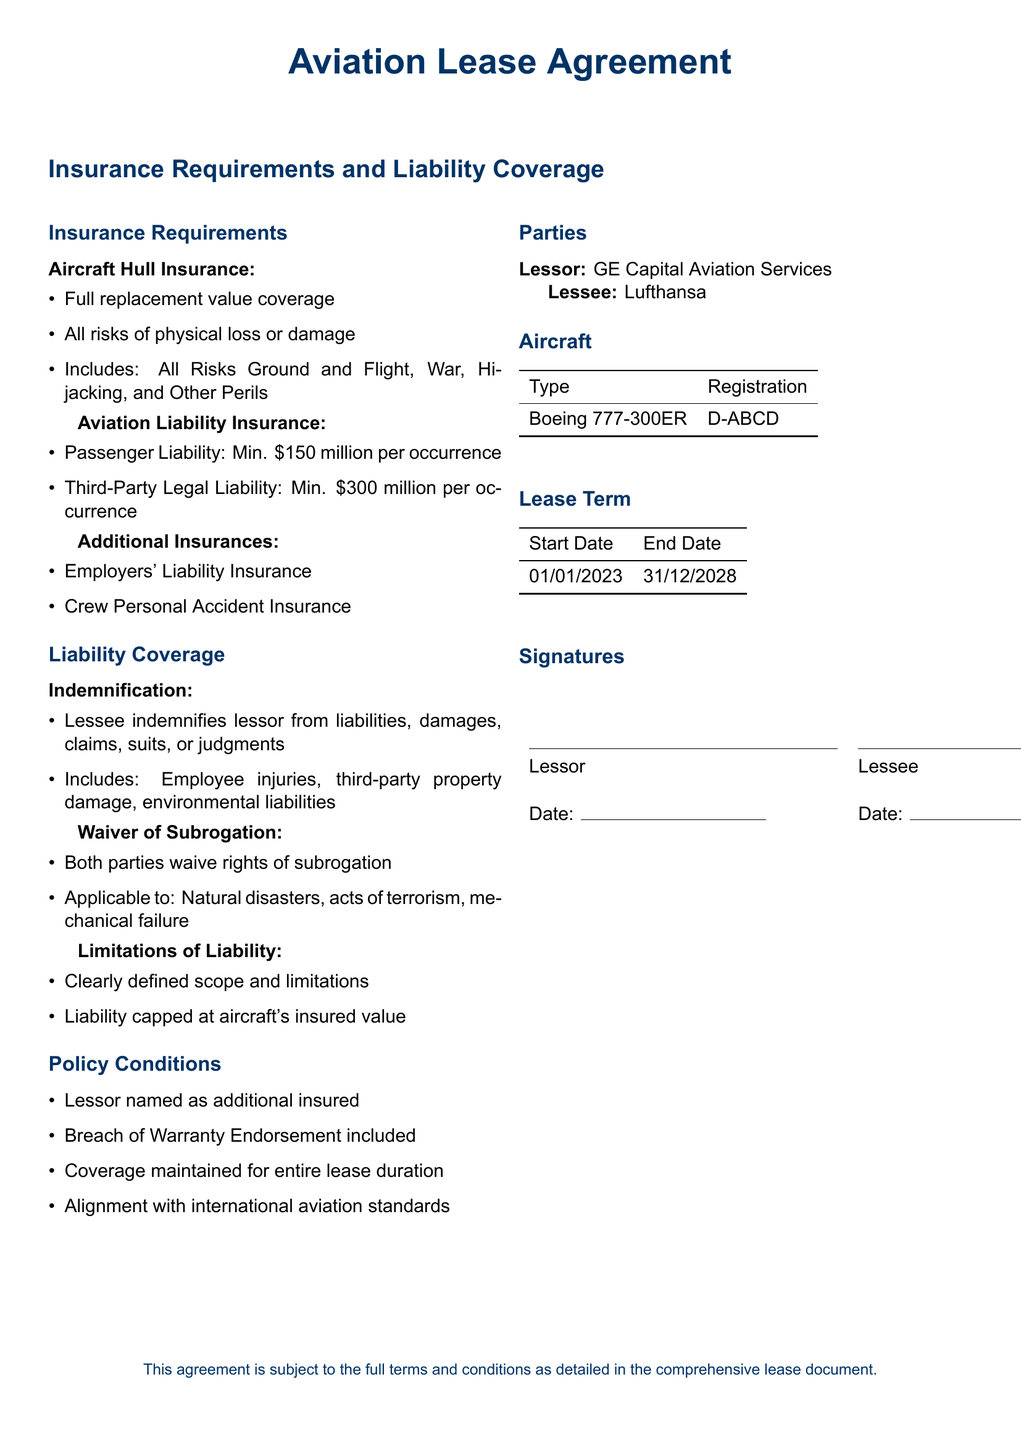What type of insurance is required for the aircraft? The document specifies that Aircraft Hull Insurance is required, covering full replacement value and all risks of physical loss or damage.
Answer: Aircraft Hull Insurance What is the minimum passenger liability coverage per occurrence? The document states that the minimum passenger liability coverage is set at 150 million.
Answer: 150 million Who is the lessor in this agreement? The lessor, as mentioned in the document, is GE Capital Aviation Services.
Answer: GE Capital Aviation Services What is the limit of liability according to the document? The document indicates that liability is capped at the aircraft's insured value.
Answer: Aircraft's insured value What type of aircraft is mentioned in the lease agreement? The document specifies a Boeing 777-300ER as the aircraft involved in the lease.
Answer: Boeing 777-300ER What is the start date of the lease term? The lease term starts on January 1, 2023, according to the document.
Answer: January 1, 2023 What must be included in the indemnification clause? The document states that indemnification must include employee injuries, third-party property damage, and environmental liabilities.
Answer: Employee injuries, third-party property damage, environmental liabilities What must be maintained for the entire lease duration? According to the policy conditions, coverage must be maintained throughout the entire lease duration.
Answer: Coverage What type of waiver is included in the agreement? The document includes a waiver of subrogation for both parties.
Answer: Waiver of subrogation 